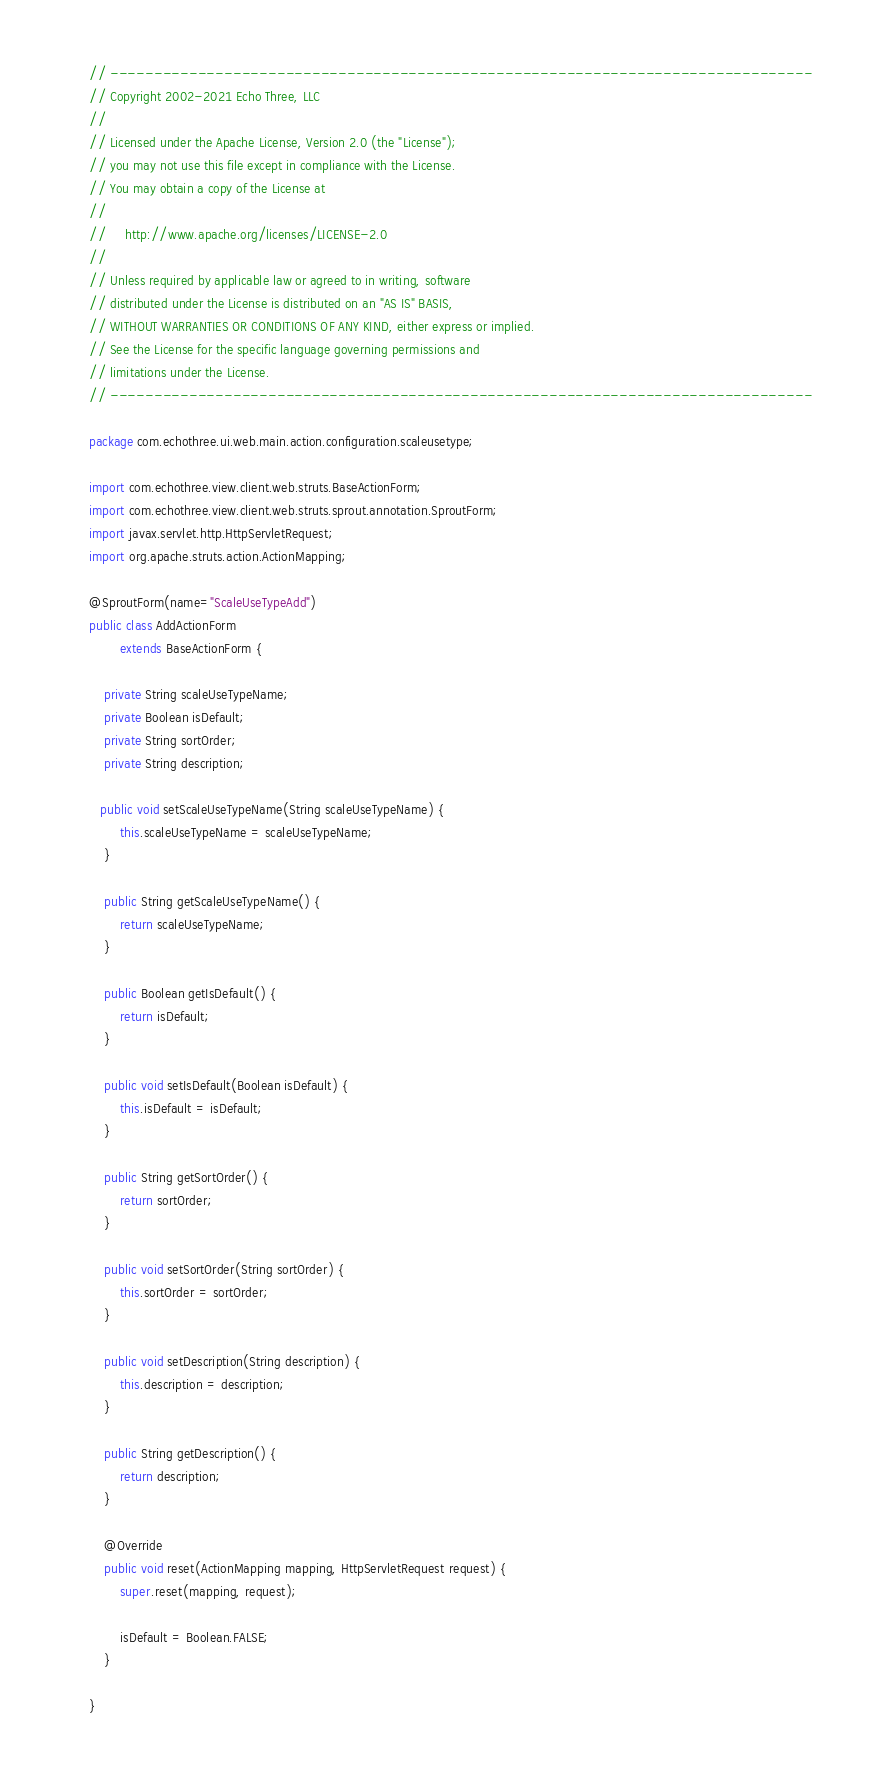<code> <loc_0><loc_0><loc_500><loc_500><_Java_>// --------------------------------------------------------------------------------
// Copyright 2002-2021 Echo Three, LLC
//
// Licensed under the Apache License, Version 2.0 (the "License");
// you may not use this file except in compliance with the License.
// You may obtain a copy of the License at
//
//     http://www.apache.org/licenses/LICENSE-2.0
//
// Unless required by applicable law or agreed to in writing, software
// distributed under the License is distributed on an "AS IS" BASIS,
// WITHOUT WARRANTIES OR CONDITIONS OF ANY KIND, either express or implied.
// See the License for the specific language governing permissions and
// limitations under the License.
// --------------------------------------------------------------------------------

package com.echothree.ui.web.main.action.configuration.scaleusetype;

import com.echothree.view.client.web.struts.BaseActionForm;
import com.echothree.view.client.web.struts.sprout.annotation.SproutForm;
import javax.servlet.http.HttpServletRequest;
import org.apache.struts.action.ActionMapping;

@SproutForm(name="ScaleUseTypeAdd")
public class AddActionForm
        extends BaseActionForm {
    
    private String scaleUseTypeName;
    private Boolean isDefault;
    private String sortOrder;
    private String description;
    
   public void setScaleUseTypeName(String scaleUseTypeName) {
        this.scaleUseTypeName = scaleUseTypeName;
    }
    
    public String getScaleUseTypeName() {
        return scaleUseTypeName;
    }
    
    public Boolean getIsDefault() {
        return isDefault;
    }
    
    public void setIsDefault(Boolean isDefault) {
        this.isDefault = isDefault;
    }
    
    public String getSortOrder() {
        return sortOrder;
    }
    
    public void setSortOrder(String sortOrder) {
        this.sortOrder = sortOrder;
    }
    
    public void setDescription(String description) {
        this.description = description;
    }
    
    public String getDescription() {
        return description;
    }
    
    @Override
    public void reset(ActionMapping mapping, HttpServletRequest request) {
        super.reset(mapping, request);
        
        isDefault = Boolean.FALSE;
    }

}
</code> 